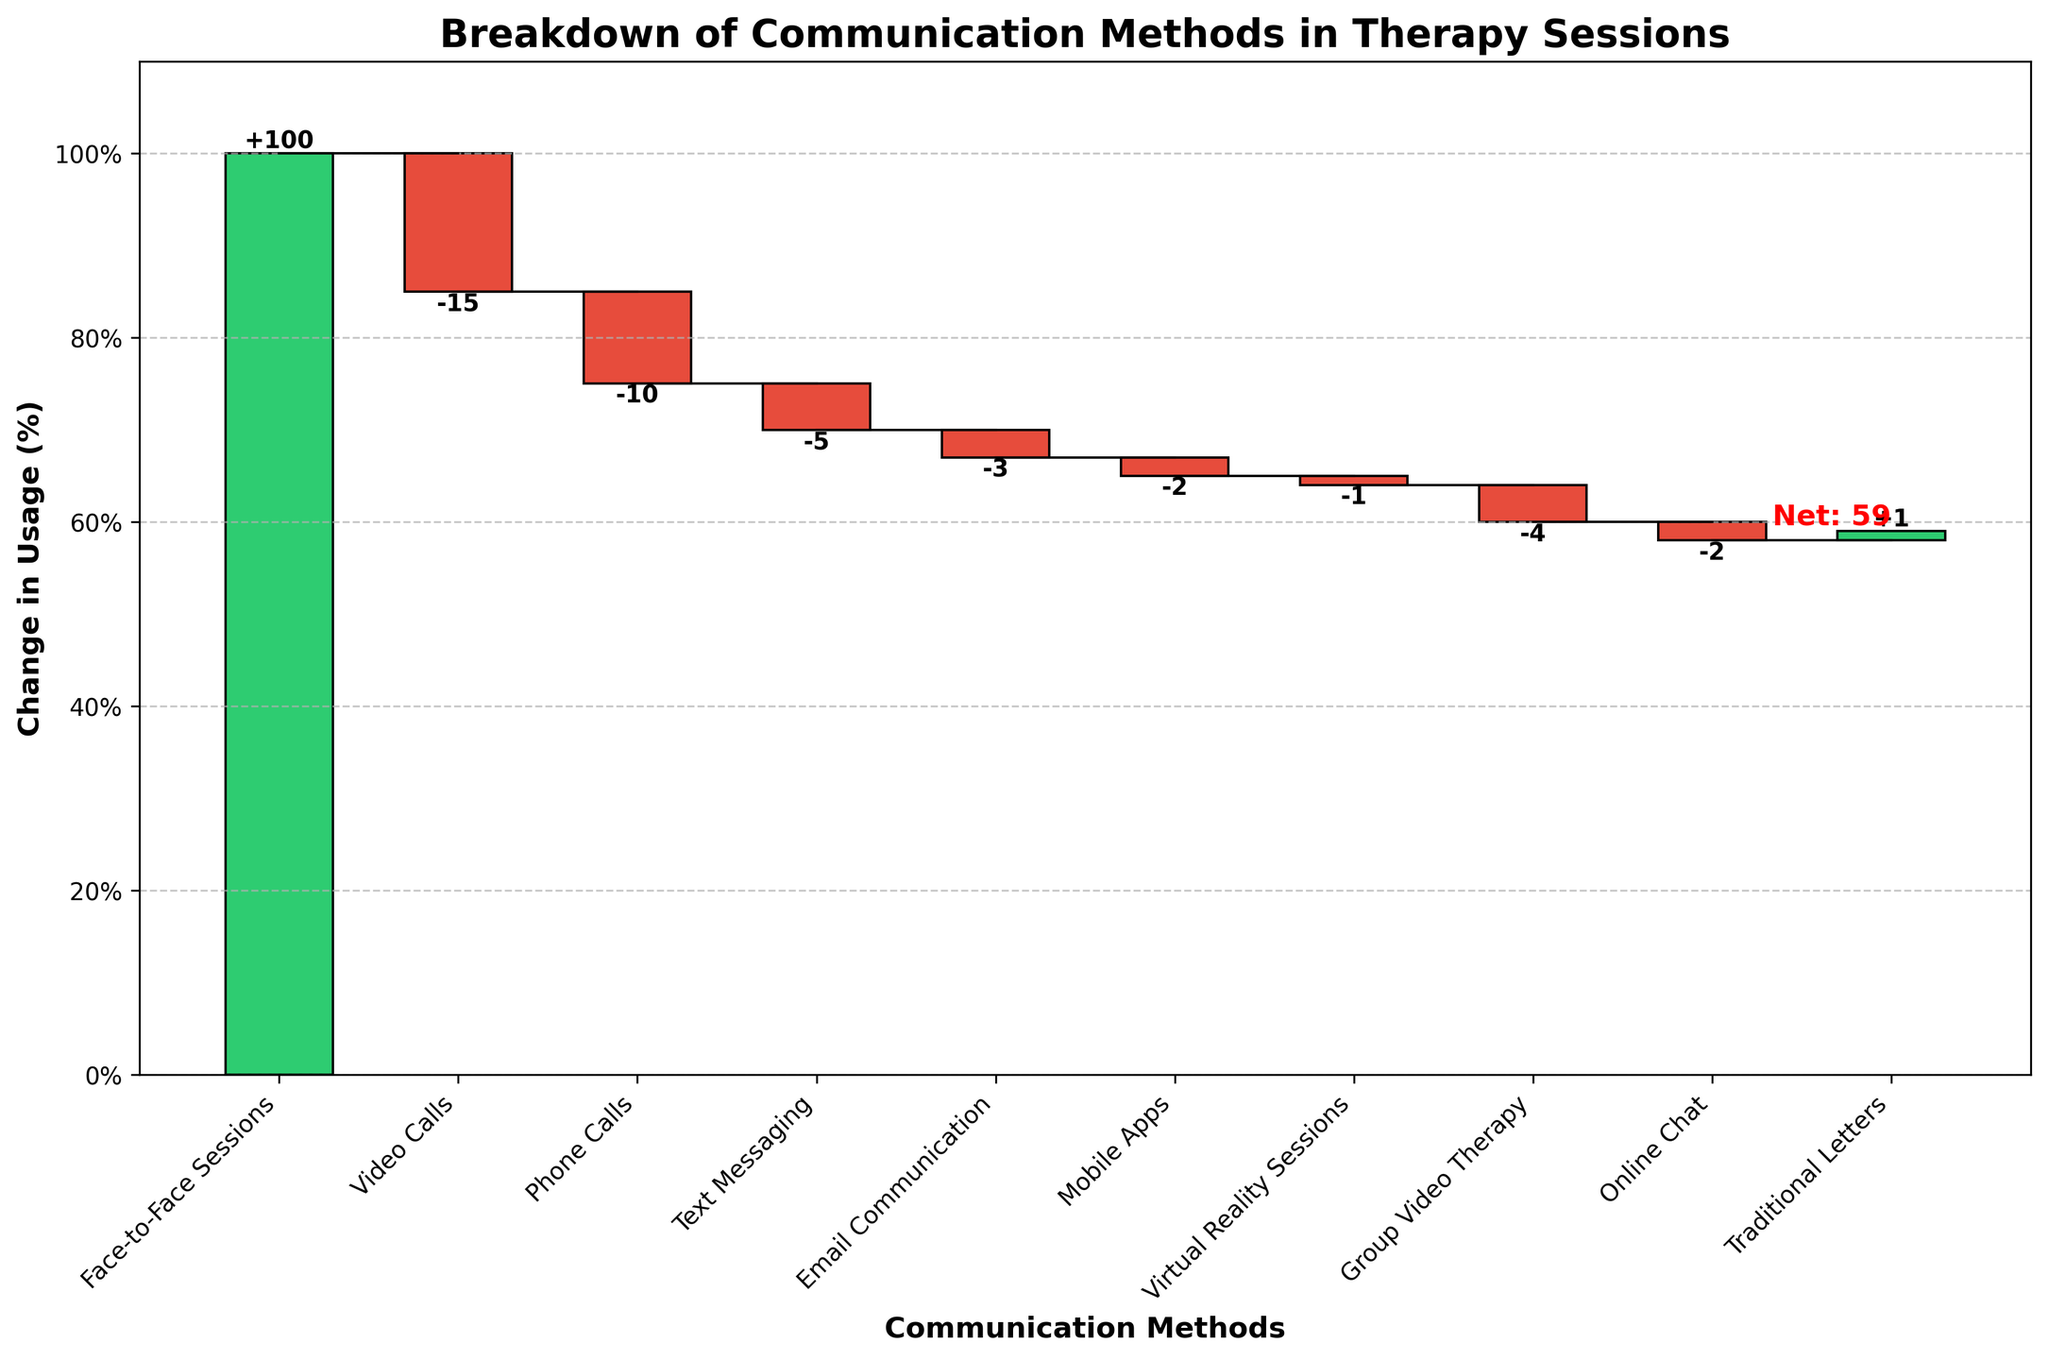What is the title of the waterfall chart? The title is usually the largest text at the top of the figure. In this case, it reads "Breakdown of Communication Methods in Therapy Sessions".
Answer: Breakdown of Communication Methods in Therapy Sessions How many methods of communication are represented in the chart? Each bar represents a method of communication, excluding the net value label. There are 10 methods listed.
Answer: 10 What is the difference in percentage points between Face-to-Face Sessions and Video Calls? The figure shows Face-to-Face Sessions at +100% and Video Calls at -15%. The difference is calculated as 100 - (-15) = 115 percentage points.
Answer: 115 Which communication method shows the highest increase in usage? By observing the tallest positive bar, Face-to-Face Sessions is the highest, increasing by +100%.
Answer: Face-to-Face Sessions Which communication method had a decrease in usage but with the smallest absolute value? To find the smallest decrease, look for the smallest negative bar. Virtual Reality Sessions shows -1%, which is the smallest absolute decrease.
Answer: Virtual Reality Sessions What is the overall net change in usage across all communication methods? The net change value is typically labeled separately in waterfall charts, displayed here as +59%.
Answer: +59% What cumulative percentage do Phone Calls contribute to after Video Calls? First find where Video Calls end, which is -15%, then add the Phone Calls value of -10%, resulting in -25%.
Answer: -25% Which method has a decrease in usage greater than -3% but less than -5%? Look at the bars within this range. Group Video Therapy is at -4%, which fits the criterion.
Answer: Group Video Therapy How does the usage of Text Messaging compare to that of Mobile Apps? Text Messaging shows -5% while Mobile Apps shows -2%. Text Messaging had a larger decrease in usage than Mobile Apps.
Answer: Text Messaging decreased more What percentage change is represented by Traditional Letters? Traditional Letters is represented by a positive bar with a value of +1%.
Answer: +1% 